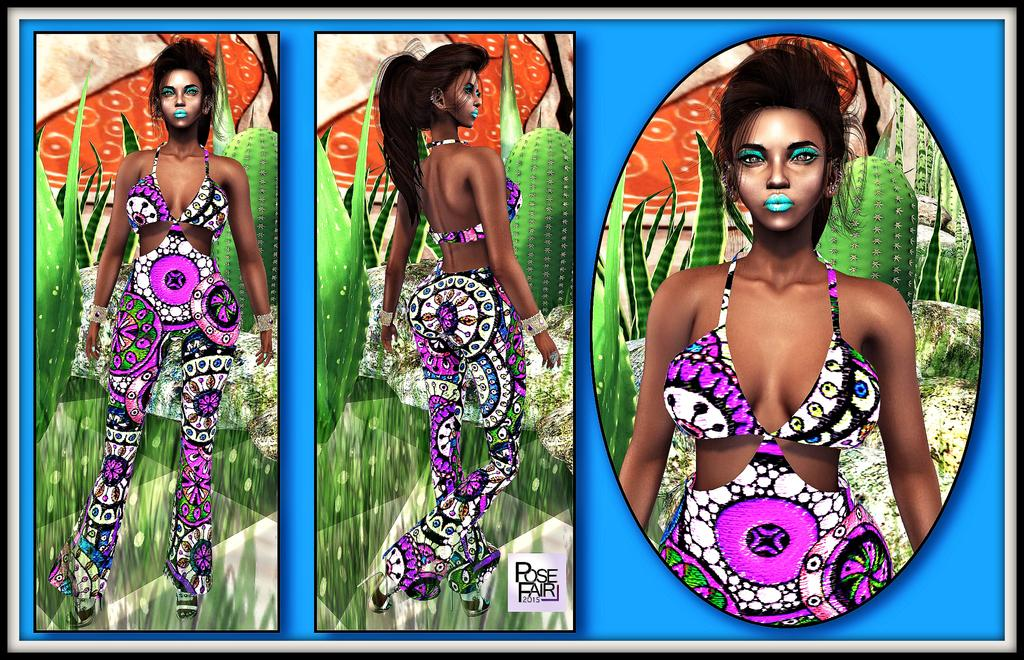What can be seen on the walls in the image? There are posters in the image. Can you describe the posters in more detail? Unfortunately, the provided facts do not give any additional information about the posters. What letter is written on the bottle in the image? There is no bottle present in the image, so it is not possible to answer that question. 